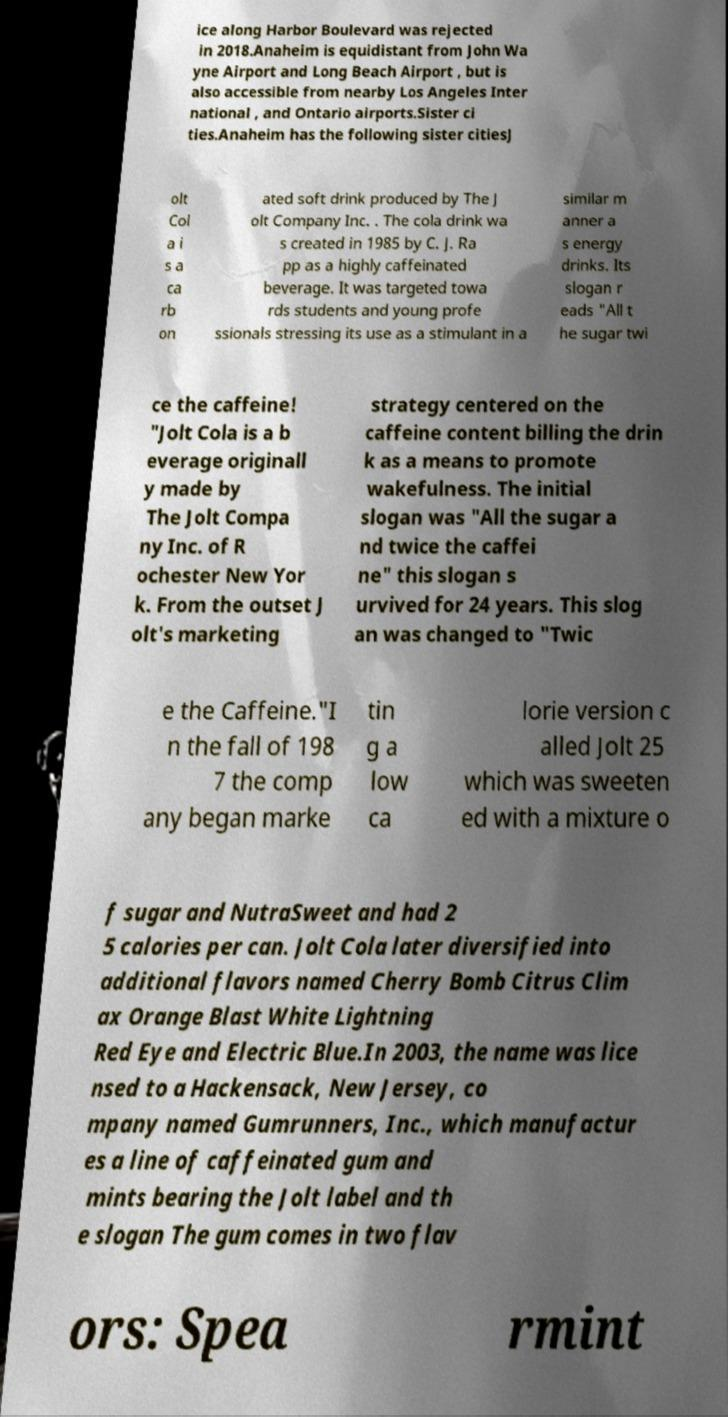Can you read and provide the text displayed in the image?This photo seems to have some interesting text. Can you extract and type it out for me? ice along Harbor Boulevard was rejected in 2018.Anaheim is equidistant from John Wa yne Airport and Long Beach Airport , but is also accessible from nearby Los Angeles Inter national , and Ontario airports.Sister ci ties.Anaheim has the following sister citiesJ olt Col a i s a ca rb on ated soft drink produced by The J olt Company Inc. . The cola drink wa s created in 1985 by C. J. Ra pp as a highly caffeinated beverage. It was targeted towa rds students and young profe ssionals stressing its use as a stimulant in a similar m anner a s energy drinks. Its slogan r eads "All t he sugar twi ce the caffeine! "Jolt Cola is a b everage originall y made by The Jolt Compa ny Inc. of R ochester New Yor k. From the outset J olt's marketing strategy centered on the caffeine content billing the drin k as a means to promote wakefulness. The initial slogan was "All the sugar a nd twice the caffei ne" this slogan s urvived for 24 years. This slog an was changed to "Twic e the Caffeine."I n the fall of 198 7 the comp any began marke tin g a low ca lorie version c alled Jolt 25 which was sweeten ed with a mixture o f sugar and NutraSweet and had 2 5 calories per can. Jolt Cola later diversified into additional flavors named Cherry Bomb Citrus Clim ax Orange Blast White Lightning Red Eye and Electric Blue.In 2003, the name was lice nsed to a Hackensack, New Jersey, co mpany named Gumrunners, Inc., which manufactur es a line of caffeinated gum and mints bearing the Jolt label and th e slogan The gum comes in two flav ors: Spea rmint 